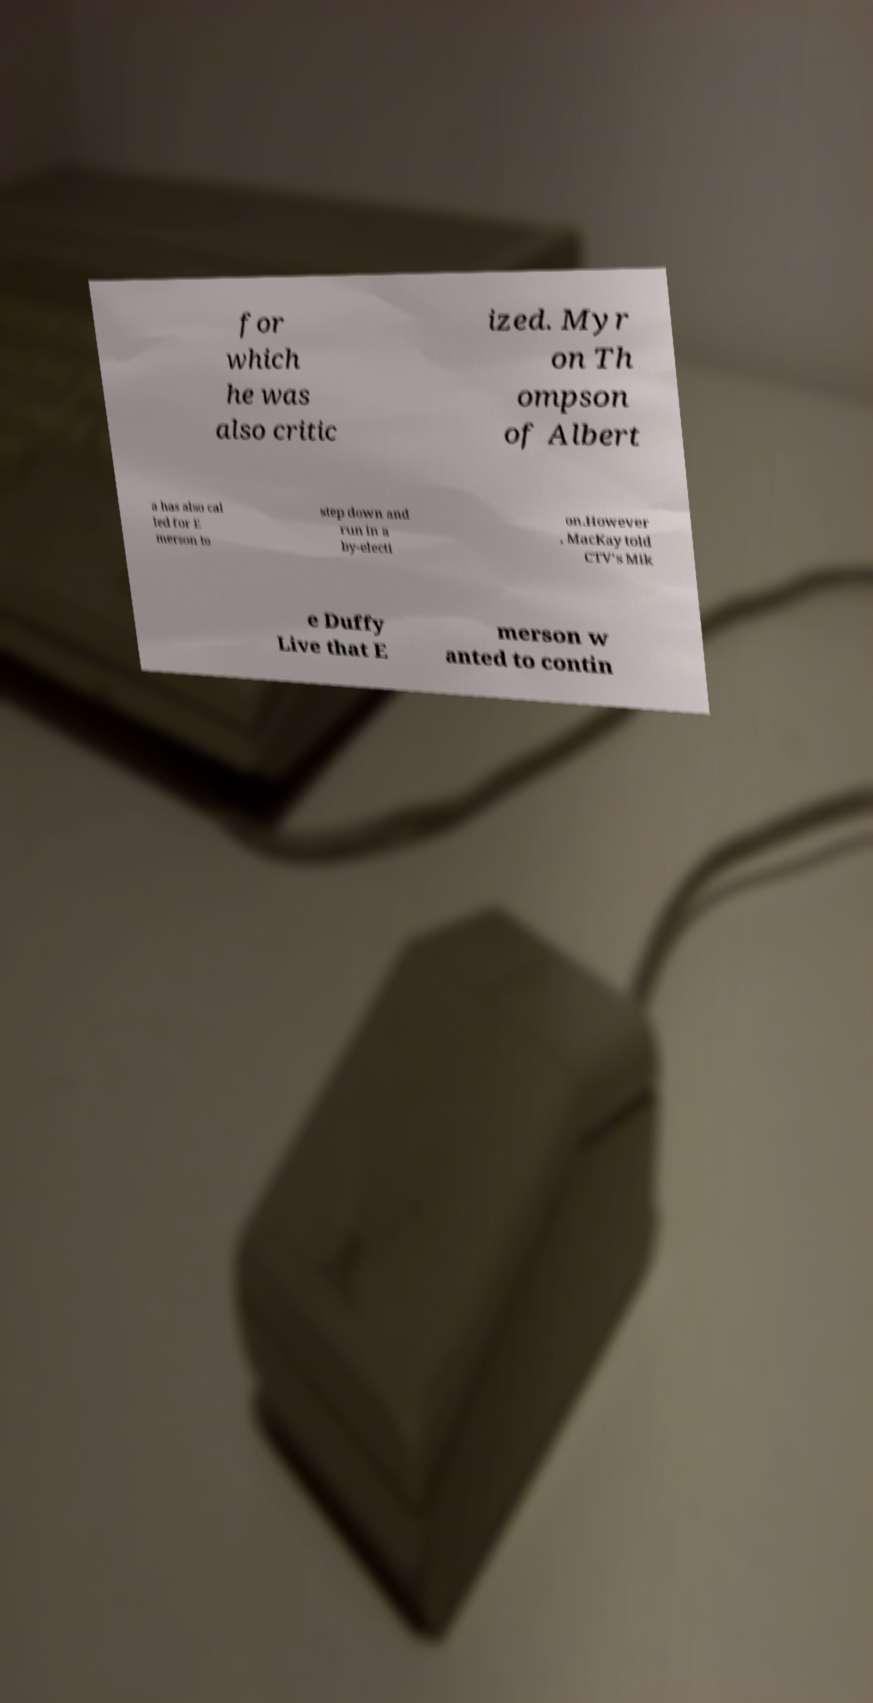For documentation purposes, I need the text within this image transcribed. Could you provide that? for which he was also critic ized. Myr on Th ompson of Albert a has also cal led for E merson to step down and run in a by-electi on.However , MacKay told CTV's Mik e Duffy Live that E merson w anted to contin 